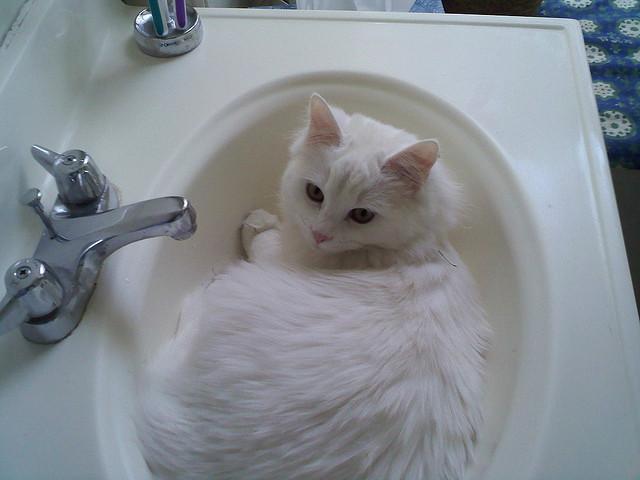How many ears does the cat have?
Give a very brief answer. 2. How many sinks are in the photo?
Give a very brief answer. 1. 